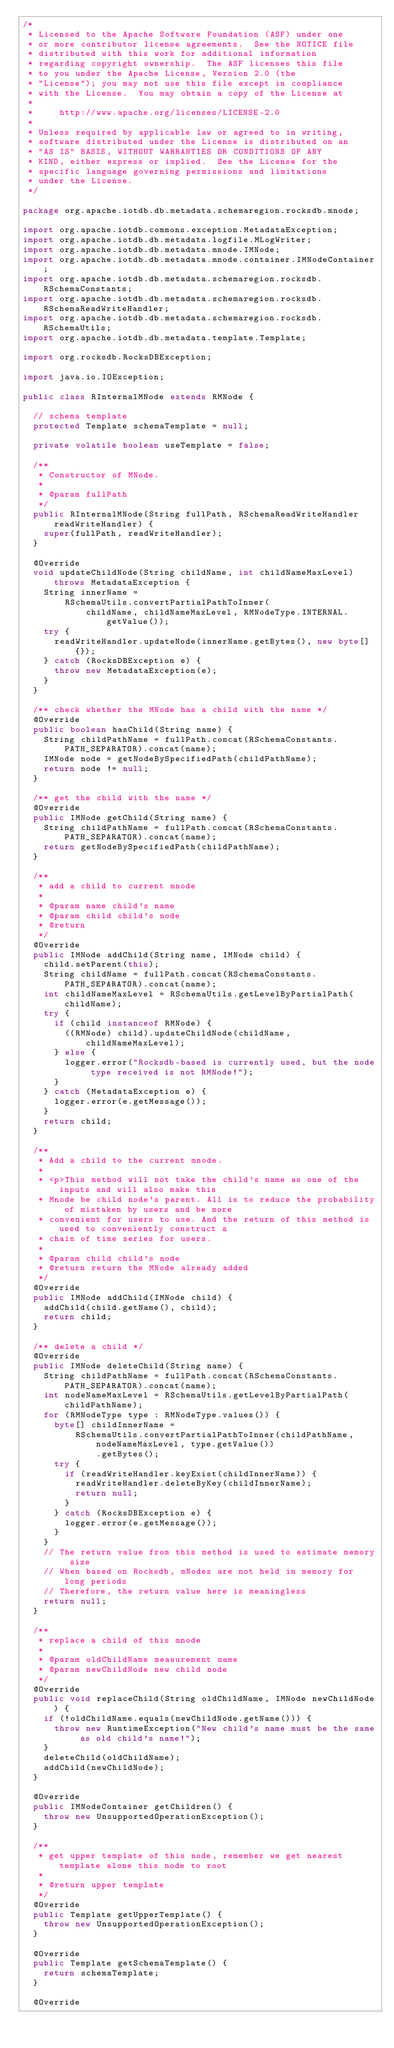<code> <loc_0><loc_0><loc_500><loc_500><_Java_>/*
 * Licensed to the Apache Software Foundation (ASF) under one
 * or more contributor license agreements.  See the NOTICE file
 * distributed with this work for additional information
 * regarding copyright ownership.  The ASF licenses this file
 * to you under the Apache License, Version 2.0 (the
 * "License"); you may not use this file except in compliance
 * with the License.  You may obtain a copy of the License at
 *
 *     http://www.apache.org/licenses/LICENSE-2.0
 *
 * Unless required by applicable law or agreed to in writing,
 * software distributed under the License is distributed on an
 * "AS IS" BASIS, WITHOUT WARRANTIES OR CONDITIONS OF ANY
 * KIND, either express or implied.  See the License for the
 * specific language governing permissions and limitations
 * under the License.
 */

package org.apache.iotdb.db.metadata.schemaregion.rocksdb.mnode;

import org.apache.iotdb.commons.exception.MetadataException;
import org.apache.iotdb.db.metadata.logfile.MLogWriter;
import org.apache.iotdb.db.metadata.mnode.IMNode;
import org.apache.iotdb.db.metadata.mnode.container.IMNodeContainer;
import org.apache.iotdb.db.metadata.schemaregion.rocksdb.RSchemaConstants;
import org.apache.iotdb.db.metadata.schemaregion.rocksdb.RSchemaReadWriteHandler;
import org.apache.iotdb.db.metadata.schemaregion.rocksdb.RSchemaUtils;
import org.apache.iotdb.db.metadata.template.Template;

import org.rocksdb.RocksDBException;

import java.io.IOException;

public class RInternalMNode extends RMNode {

  // schema template
  protected Template schemaTemplate = null;

  private volatile boolean useTemplate = false;

  /**
   * Constructor of MNode.
   *
   * @param fullPath
   */
  public RInternalMNode(String fullPath, RSchemaReadWriteHandler readWriteHandler) {
    super(fullPath, readWriteHandler);
  }

  @Override
  void updateChildNode(String childName, int childNameMaxLevel) throws MetadataException {
    String innerName =
        RSchemaUtils.convertPartialPathToInner(
            childName, childNameMaxLevel, RMNodeType.INTERNAL.getValue());
    try {
      readWriteHandler.updateNode(innerName.getBytes(), new byte[] {});
    } catch (RocksDBException e) {
      throw new MetadataException(e);
    }
  }

  /** check whether the MNode has a child with the name */
  @Override
  public boolean hasChild(String name) {
    String childPathName = fullPath.concat(RSchemaConstants.PATH_SEPARATOR).concat(name);
    IMNode node = getNodeBySpecifiedPath(childPathName);
    return node != null;
  }

  /** get the child with the name */
  @Override
  public IMNode getChild(String name) {
    String childPathName = fullPath.concat(RSchemaConstants.PATH_SEPARATOR).concat(name);
    return getNodeBySpecifiedPath(childPathName);
  }

  /**
   * add a child to current mnode
   *
   * @param name child's name
   * @param child child's node
   * @return
   */
  @Override
  public IMNode addChild(String name, IMNode child) {
    child.setParent(this);
    String childName = fullPath.concat(RSchemaConstants.PATH_SEPARATOR).concat(name);
    int childNameMaxLevel = RSchemaUtils.getLevelByPartialPath(childName);
    try {
      if (child instanceof RMNode) {
        ((RMNode) child).updateChildNode(childName, childNameMaxLevel);
      } else {
        logger.error("Rocksdb-based is currently used, but the node type received is not RMNode!");
      }
    } catch (MetadataException e) {
      logger.error(e.getMessage());
    }
    return child;
  }

  /**
   * Add a child to the current mnode.
   *
   * <p>This method will not take the child's name as one of the inputs and will also make this
   * Mnode be child node's parent. All is to reduce the probability of mistaken by users and be more
   * convenient for users to use. And the return of this method is used to conveniently construct a
   * chain of time series for users.
   *
   * @param child child's node
   * @return return the MNode already added
   */
  @Override
  public IMNode addChild(IMNode child) {
    addChild(child.getName(), child);
    return child;
  }

  /** delete a child */
  @Override
  public IMNode deleteChild(String name) {
    String childPathName = fullPath.concat(RSchemaConstants.PATH_SEPARATOR).concat(name);
    int nodeNameMaxLevel = RSchemaUtils.getLevelByPartialPath(childPathName);
    for (RMNodeType type : RMNodeType.values()) {
      byte[] childInnerName =
          RSchemaUtils.convertPartialPathToInner(childPathName, nodeNameMaxLevel, type.getValue())
              .getBytes();
      try {
        if (readWriteHandler.keyExist(childInnerName)) {
          readWriteHandler.deleteByKey(childInnerName);
          return null;
        }
      } catch (RocksDBException e) {
        logger.error(e.getMessage());
      }
    }
    // The return value from this method is used to estimate memory size
    // When based on Rocksdb, mNodes are not held in memory for long periods
    // Therefore, the return value here is meaningless
    return null;
  }

  /**
   * replace a child of this mnode
   *
   * @param oldChildName measurement name
   * @param newChildNode new child node
   */
  @Override
  public void replaceChild(String oldChildName, IMNode newChildNode) {
    if (!oldChildName.equals(newChildNode.getName())) {
      throw new RuntimeException("New child's name must be the same as old child's name!");
    }
    deleteChild(oldChildName);
    addChild(newChildNode);
  }

  @Override
  public IMNodeContainer getChildren() {
    throw new UnsupportedOperationException();
  }

  /**
   * get upper template of this node, remember we get nearest template alone this node to root
   *
   * @return upper template
   */
  @Override
  public Template getUpperTemplate() {
    throw new UnsupportedOperationException();
  }

  @Override
  public Template getSchemaTemplate() {
    return schemaTemplate;
  }

  @Override</code> 